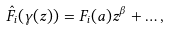Convert formula to latex. <formula><loc_0><loc_0><loc_500><loc_500>\hat { F } _ { i } ( \gamma ( z ) ) = F _ { i } ( a ) z ^ { \beta } + \dots ,</formula> 